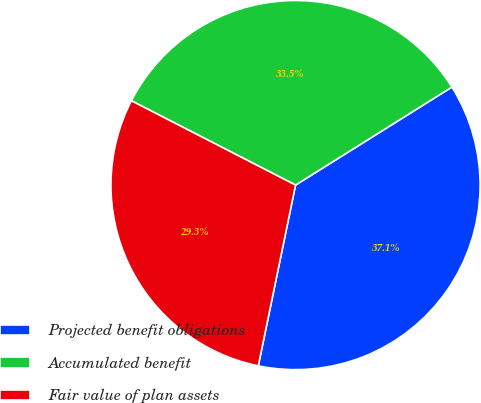Convert chart. <chart><loc_0><loc_0><loc_500><loc_500><pie_chart><fcel>Projected benefit obligations<fcel>Accumulated benefit<fcel>Fair value of plan assets<nl><fcel>37.15%<fcel>33.54%<fcel>29.32%<nl></chart> 